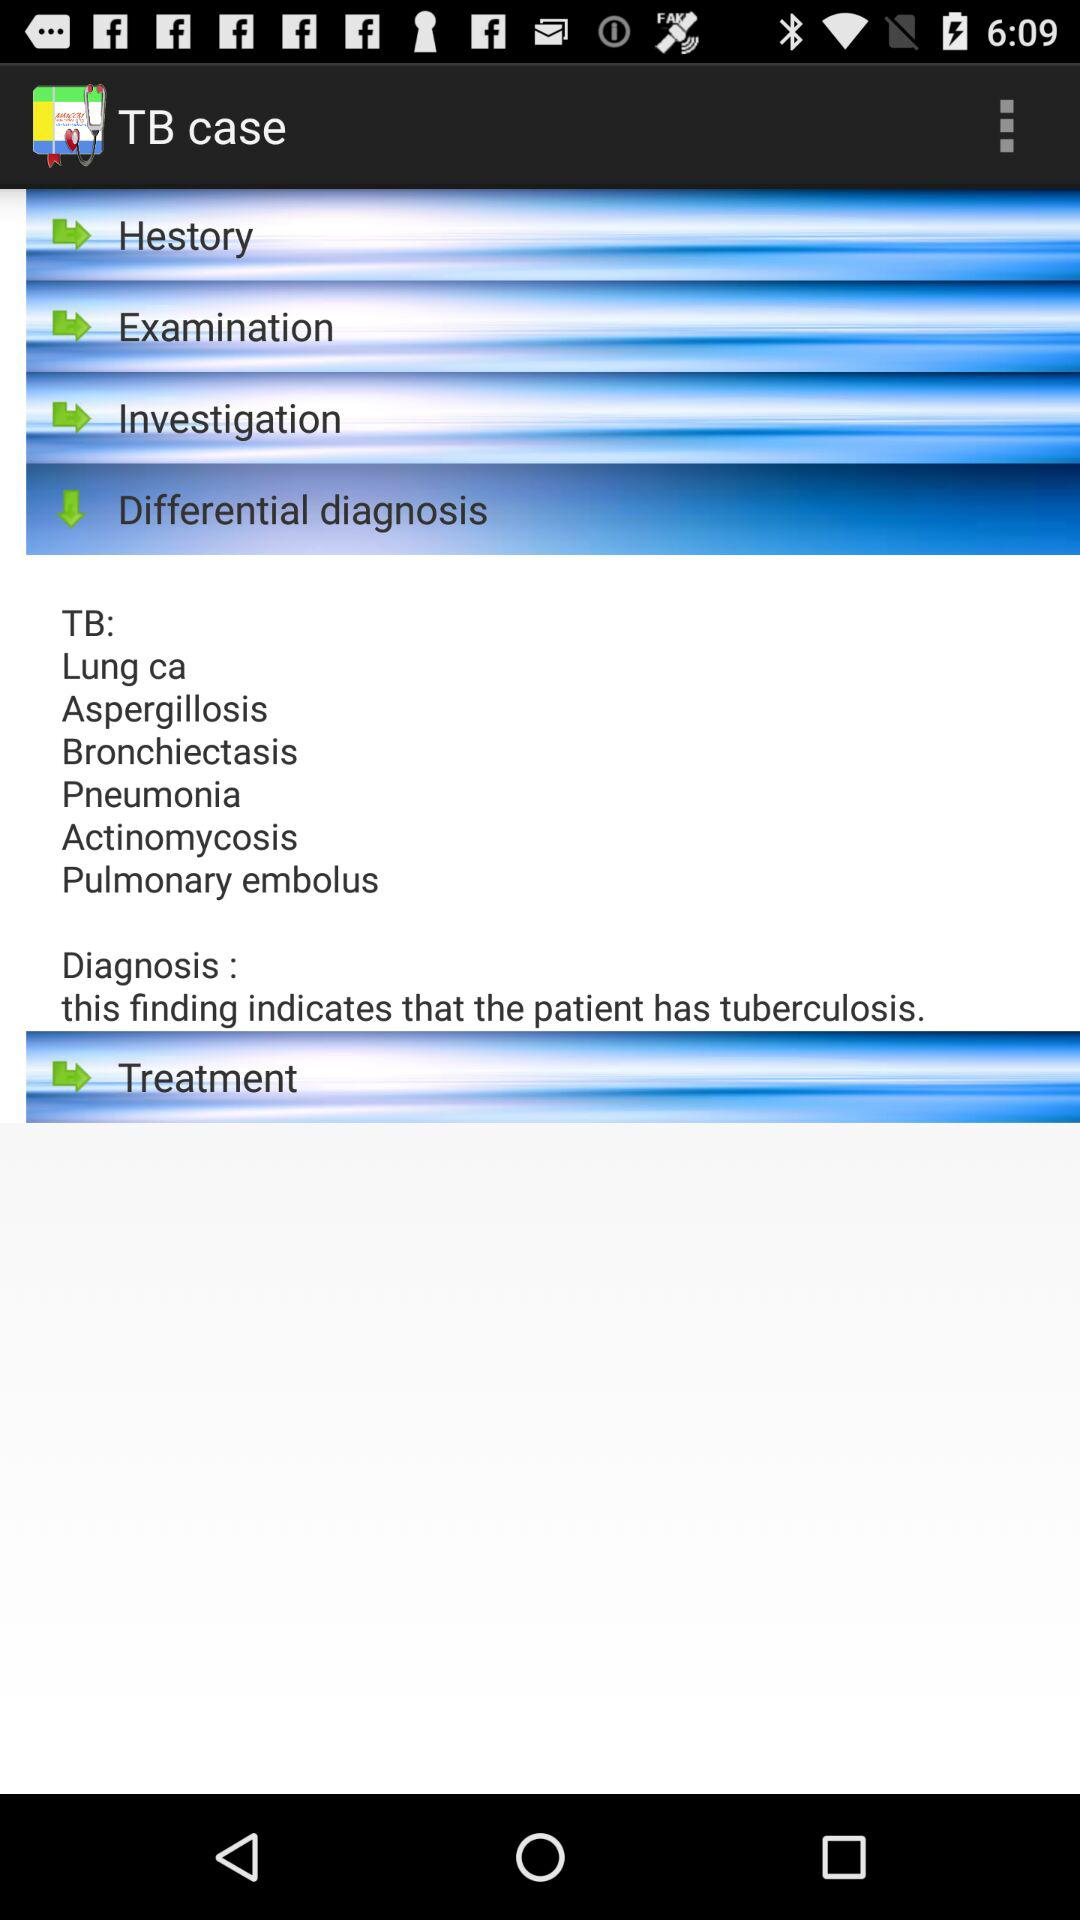What is the name of the application? The name of the application is "Clinical Skills". 